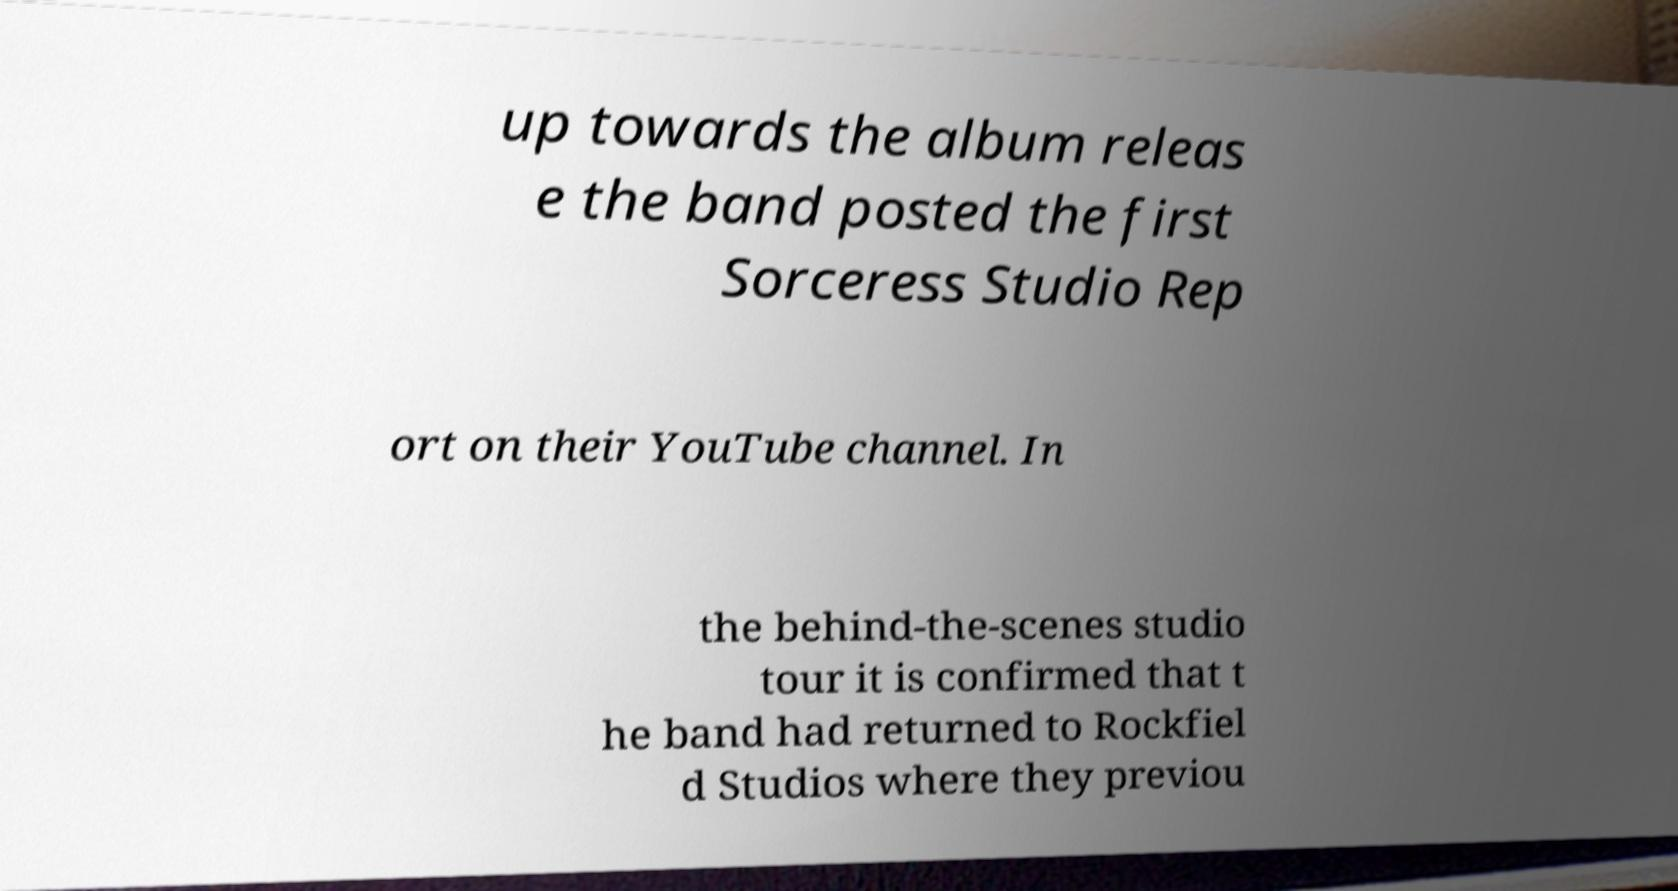What messages or text are displayed in this image? I need them in a readable, typed format. up towards the album releas e the band posted the first Sorceress Studio Rep ort on their YouTube channel. In the behind-the-scenes studio tour it is confirmed that t he band had returned to Rockfiel d Studios where they previou 